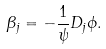<formula> <loc_0><loc_0><loc_500><loc_500>\beta _ { j } = - \frac { 1 } { \psi } D _ { j } \phi .</formula> 